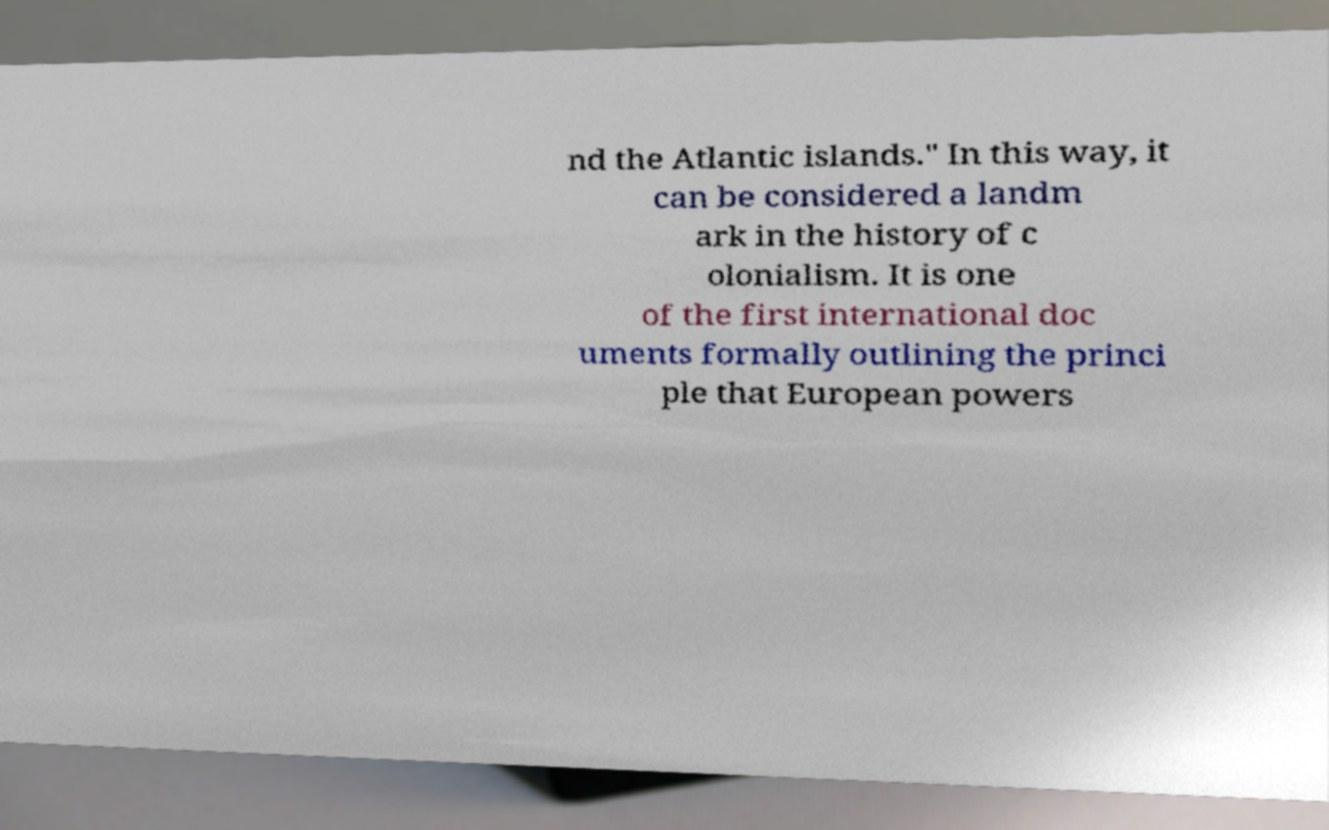I need the written content from this picture converted into text. Can you do that? nd the Atlantic islands." In this way, it can be considered a landm ark in the history of c olonialism. It is one of the first international doc uments formally outlining the princi ple that European powers 